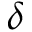<formula> <loc_0><loc_0><loc_500><loc_500>\delta</formula> 